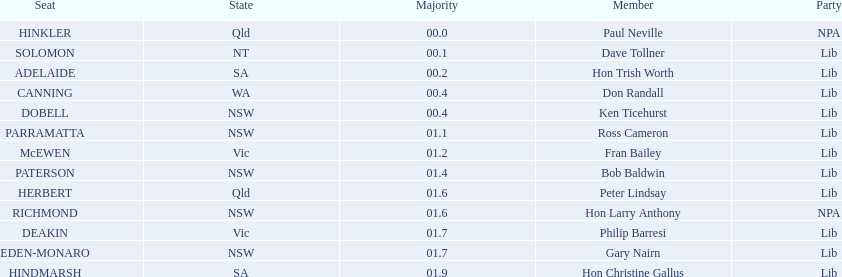Who makes up the liberal party membership? Dave Tollner, Hon Trish Worth, Don Randall, Ken Ticehurst, Ross Cameron, Fran Bailey, Bob Baldwin, Peter Lindsay, Philip Barresi, Gary Nairn, Hon Christine Gallus. Are there any members from south australia? Hon Trish Worth, Hon Christine Gallus. What's the biggest majority gap between south australian members? 01.9. 